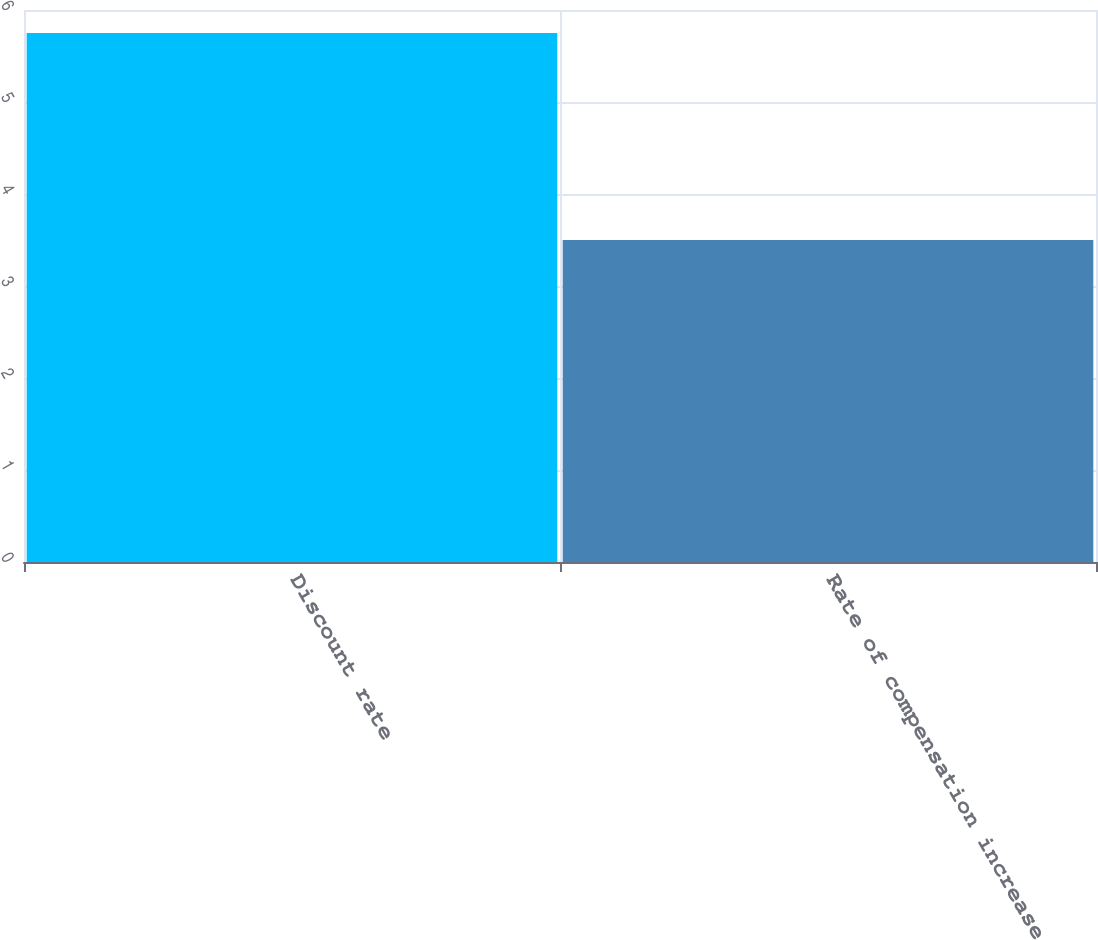Convert chart. <chart><loc_0><loc_0><loc_500><loc_500><bar_chart><fcel>Discount rate<fcel>Rate of compensation increase<nl><fcel>5.75<fcel>3.5<nl></chart> 